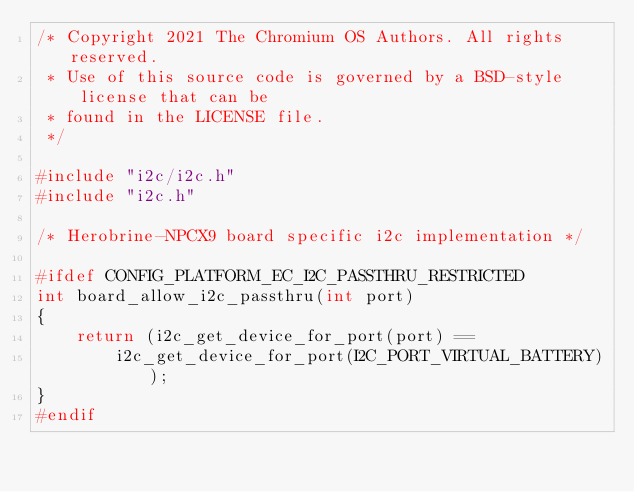<code> <loc_0><loc_0><loc_500><loc_500><_C_>/* Copyright 2021 The Chromium OS Authors. All rights reserved.
 * Use of this source code is governed by a BSD-style license that can be
 * found in the LICENSE file.
 */

#include "i2c/i2c.h"
#include "i2c.h"

/* Herobrine-NPCX9 board specific i2c implementation */

#ifdef CONFIG_PLATFORM_EC_I2C_PASSTHRU_RESTRICTED
int board_allow_i2c_passthru(int port)
{
	return (i2c_get_device_for_port(port) ==
		i2c_get_device_for_port(I2C_PORT_VIRTUAL_BATTERY));
}
#endif
</code> 